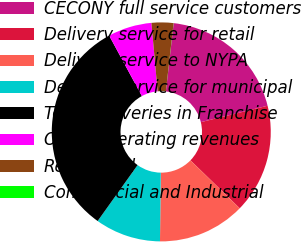Convert chart. <chart><loc_0><loc_0><loc_500><loc_500><pie_chart><fcel>CECONY full service customers<fcel>Delivery service for retail<fcel>Delivery service to NYPA<fcel>Delivery service for municipal<fcel>Total Deliveries in Franchise<fcel>Other operating revenues<fcel>Residential<fcel>Commercial and Industrial<nl><fcel>19.35%<fcel>16.13%<fcel>12.9%<fcel>9.68%<fcel>32.24%<fcel>6.46%<fcel>3.23%<fcel>0.01%<nl></chart> 